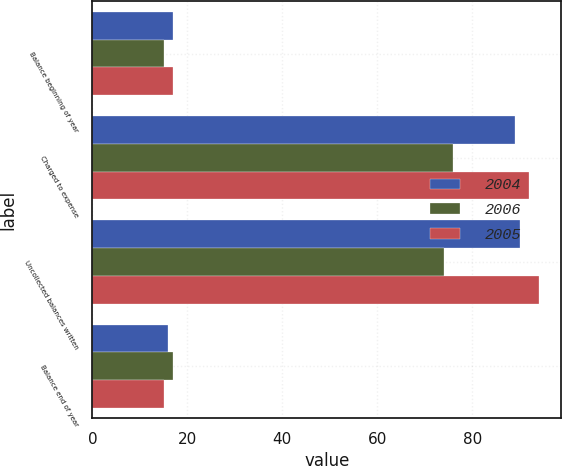Convert chart to OTSL. <chart><loc_0><loc_0><loc_500><loc_500><stacked_bar_chart><ecel><fcel>Balance beginning of year<fcel>Charged to expense<fcel>Uncollected balances written<fcel>Balance end of year<nl><fcel>2004<fcel>17<fcel>89<fcel>90<fcel>16<nl><fcel>2006<fcel>15<fcel>76<fcel>74<fcel>17<nl><fcel>2005<fcel>17<fcel>92<fcel>94<fcel>15<nl></chart> 